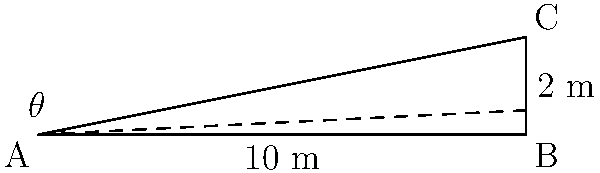At a hardcore punk concert, the venue wants to create a sloped floor for the mosh pit to improve visibility. The floor needs to rise 2 meters over a horizontal distance of 10 meters. What is the angle of inclination (θ) of the mosh pit floor? Use inverse trigonometric functions and round your answer to the nearest degree. To find the angle of inclination (θ), we can use the inverse tangent function (arctan or tan^(-1)). Here's how we solve it step-by-step:

1) In a right triangle, tan(θ) = opposite / adjacent
   
2) In this case:
   - The opposite side (rise) is 2 meters
   - The adjacent side (run) is 10 meters

3) So, we have:
   tan(θ) = 2 / 10 = 0.2

4) To find θ, we need to use the inverse tangent function:
   θ = tan^(-1)(0.2)

5) Using a calculator or trigonometric tables:
   θ ≈ 11.31 degrees

6) Rounding to the nearest degree:
   θ ≈ 11 degrees

Therefore, the angle of inclination of the mosh pit floor is approximately 11 degrees.
Answer: 11° 